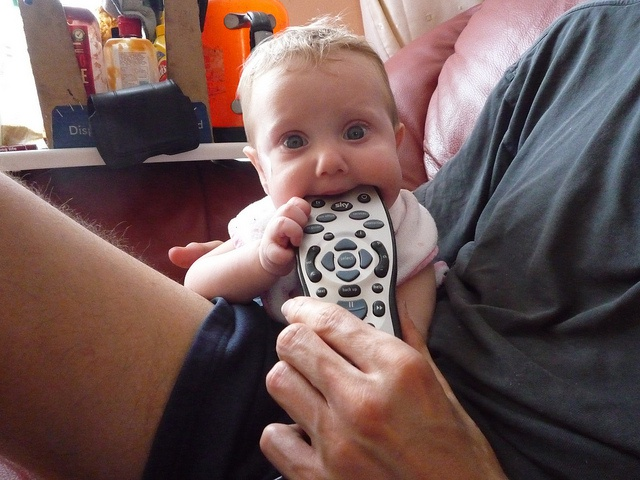Describe the objects in this image and their specific colors. I can see people in white, black, maroon, gray, and brown tones, people in white, brown, and lightpink tones, and remote in white, lightgray, gray, black, and darkgray tones in this image. 